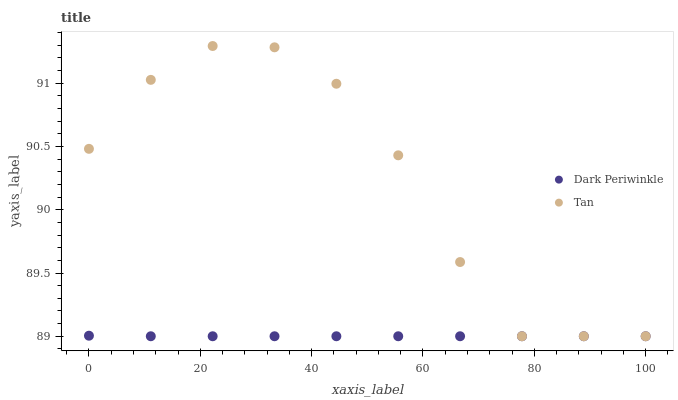Does Dark Periwinkle have the minimum area under the curve?
Answer yes or no. Yes. Does Tan have the maximum area under the curve?
Answer yes or no. Yes. Does Dark Periwinkle have the maximum area under the curve?
Answer yes or no. No. Is Dark Periwinkle the smoothest?
Answer yes or no. Yes. Is Tan the roughest?
Answer yes or no. Yes. Is Dark Periwinkle the roughest?
Answer yes or no. No. Does Tan have the lowest value?
Answer yes or no. Yes. Does Tan have the highest value?
Answer yes or no. Yes. Does Dark Periwinkle have the highest value?
Answer yes or no. No. Does Dark Periwinkle intersect Tan?
Answer yes or no. Yes. Is Dark Periwinkle less than Tan?
Answer yes or no. No. Is Dark Periwinkle greater than Tan?
Answer yes or no. No. 